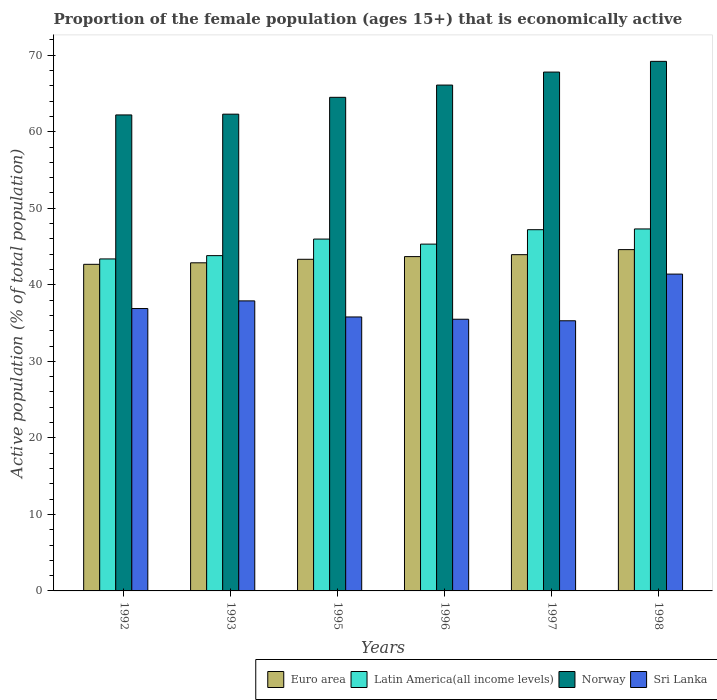How many groups of bars are there?
Offer a very short reply. 6. Are the number of bars per tick equal to the number of legend labels?
Ensure brevity in your answer.  Yes. Are the number of bars on each tick of the X-axis equal?
Provide a short and direct response. Yes. How many bars are there on the 2nd tick from the left?
Make the answer very short. 4. How many bars are there on the 6th tick from the right?
Provide a short and direct response. 4. What is the label of the 6th group of bars from the left?
Keep it short and to the point. 1998. What is the proportion of the female population that is economically active in Euro area in 1996?
Give a very brief answer. 43.69. Across all years, what is the maximum proportion of the female population that is economically active in Euro area?
Make the answer very short. 44.6. Across all years, what is the minimum proportion of the female population that is economically active in Norway?
Keep it short and to the point. 62.2. In which year was the proportion of the female population that is economically active in Latin America(all income levels) minimum?
Provide a succinct answer. 1992. What is the total proportion of the female population that is economically active in Norway in the graph?
Your answer should be very brief. 392.1. What is the difference between the proportion of the female population that is economically active in Latin America(all income levels) in 1995 and that in 1997?
Provide a short and direct response. -1.22. What is the difference between the proportion of the female population that is economically active in Sri Lanka in 1997 and the proportion of the female population that is economically active in Norway in 1998?
Keep it short and to the point. -33.9. What is the average proportion of the female population that is economically active in Euro area per year?
Ensure brevity in your answer.  43.52. In the year 1992, what is the difference between the proportion of the female population that is economically active in Latin America(all income levels) and proportion of the female population that is economically active in Norway?
Make the answer very short. -18.82. What is the ratio of the proportion of the female population that is economically active in Sri Lanka in 1993 to that in 1997?
Give a very brief answer. 1.07. Is the proportion of the female population that is economically active in Sri Lanka in 1992 less than that in 1997?
Your response must be concise. No. What is the difference between the highest and the second highest proportion of the female population that is economically active in Euro area?
Ensure brevity in your answer.  0.66. What is the difference between the highest and the lowest proportion of the female population that is economically active in Sri Lanka?
Make the answer very short. 6.1. In how many years, is the proportion of the female population that is economically active in Sri Lanka greater than the average proportion of the female population that is economically active in Sri Lanka taken over all years?
Offer a very short reply. 2. Is the sum of the proportion of the female population that is economically active in Sri Lanka in 1997 and 1998 greater than the maximum proportion of the female population that is economically active in Latin America(all income levels) across all years?
Provide a succinct answer. Yes. Is it the case that in every year, the sum of the proportion of the female population that is economically active in Latin America(all income levels) and proportion of the female population that is economically active in Euro area is greater than the sum of proportion of the female population that is economically active in Sri Lanka and proportion of the female population that is economically active in Norway?
Your answer should be very brief. No. What does the 2nd bar from the left in 1995 represents?
Make the answer very short. Latin America(all income levels). Are all the bars in the graph horizontal?
Offer a very short reply. No. How many years are there in the graph?
Provide a succinct answer. 6. Are the values on the major ticks of Y-axis written in scientific E-notation?
Give a very brief answer. No. Does the graph contain grids?
Give a very brief answer. No. Where does the legend appear in the graph?
Keep it short and to the point. Bottom right. How are the legend labels stacked?
Offer a very short reply. Horizontal. What is the title of the graph?
Offer a very short reply. Proportion of the female population (ages 15+) that is economically active. What is the label or title of the X-axis?
Make the answer very short. Years. What is the label or title of the Y-axis?
Your answer should be compact. Active population (% of total population). What is the Active population (% of total population) in Euro area in 1992?
Your response must be concise. 42.68. What is the Active population (% of total population) of Latin America(all income levels) in 1992?
Give a very brief answer. 43.38. What is the Active population (% of total population) of Norway in 1992?
Your answer should be very brief. 62.2. What is the Active population (% of total population) of Sri Lanka in 1992?
Keep it short and to the point. 36.9. What is the Active population (% of total population) of Euro area in 1993?
Ensure brevity in your answer.  42.88. What is the Active population (% of total population) of Latin America(all income levels) in 1993?
Ensure brevity in your answer.  43.81. What is the Active population (% of total population) of Norway in 1993?
Offer a very short reply. 62.3. What is the Active population (% of total population) of Sri Lanka in 1993?
Offer a very short reply. 37.9. What is the Active population (% of total population) in Euro area in 1995?
Offer a very short reply. 43.33. What is the Active population (% of total population) of Latin America(all income levels) in 1995?
Provide a succinct answer. 45.98. What is the Active population (% of total population) in Norway in 1995?
Keep it short and to the point. 64.5. What is the Active population (% of total population) in Sri Lanka in 1995?
Make the answer very short. 35.8. What is the Active population (% of total population) of Euro area in 1996?
Offer a terse response. 43.69. What is the Active population (% of total population) of Latin America(all income levels) in 1996?
Make the answer very short. 45.32. What is the Active population (% of total population) in Norway in 1996?
Provide a succinct answer. 66.1. What is the Active population (% of total population) of Sri Lanka in 1996?
Make the answer very short. 35.5. What is the Active population (% of total population) of Euro area in 1997?
Provide a succinct answer. 43.94. What is the Active population (% of total population) in Latin America(all income levels) in 1997?
Provide a short and direct response. 47.2. What is the Active population (% of total population) in Norway in 1997?
Offer a terse response. 67.8. What is the Active population (% of total population) in Sri Lanka in 1997?
Your response must be concise. 35.3. What is the Active population (% of total population) of Euro area in 1998?
Your answer should be very brief. 44.6. What is the Active population (% of total population) of Latin America(all income levels) in 1998?
Give a very brief answer. 47.3. What is the Active population (% of total population) in Norway in 1998?
Offer a terse response. 69.2. What is the Active population (% of total population) in Sri Lanka in 1998?
Your answer should be very brief. 41.4. Across all years, what is the maximum Active population (% of total population) of Euro area?
Your response must be concise. 44.6. Across all years, what is the maximum Active population (% of total population) of Latin America(all income levels)?
Give a very brief answer. 47.3. Across all years, what is the maximum Active population (% of total population) in Norway?
Provide a short and direct response. 69.2. Across all years, what is the maximum Active population (% of total population) in Sri Lanka?
Give a very brief answer. 41.4. Across all years, what is the minimum Active population (% of total population) in Euro area?
Ensure brevity in your answer.  42.68. Across all years, what is the minimum Active population (% of total population) of Latin America(all income levels)?
Offer a very short reply. 43.38. Across all years, what is the minimum Active population (% of total population) in Norway?
Keep it short and to the point. 62.2. Across all years, what is the minimum Active population (% of total population) in Sri Lanka?
Your response must be concise. 35.3. What is the total Active population (% of total population) of Euro area in the graph?
Offer a terse response. 261.11. What is the total Active population (% of total population) of Latin America(all income levels) in the graph?
Provide a short and direct response. 272.99. What is the total Active population (% of total population) of Norway in the graph?
Provide a short and direct response. 392.1. What is the total Active population (% of total population) in Sri Lanka in the graph?
Provide a short and direct response. 222.8. What is the difference between the Active population (% of total population) of Euro area in 1992 and that in 1993?
Offer a terse response. -0.2. What is the difference between the Active population (% of total population) of Latin America(all income levels) in 1992 and that in 1993?
Your answer should be very brief. -0.43. What is the difference between the Active population (% of total population) in Norway in 1992 and that in 1993?
Give a very brief answer. -0.1. What is the difference between the Active population (% of total population) of Euro area in 1992 and that in 1995?
Your answer should be compact. -0.66. What is the difference between the Active population (% of total population) of Latin America(all income levels) in 1992 and that in 1995?
Offer a terse response. -2.6. What is the difference between the Active population (% of total population) of Norway in 1992 and that in 1995?
Your answer should be very brief. -2.3. What is the difference between the Active population (% of total population) in Sri Lanka in 1992 and that in 1995?
Your answer should be compact. 1.1. What is the difference between the Active population (% of total population) of Euro area in 1992 and that in 1996?
Your response must be concise. -1.01. What is the difference between the Active population (% of total population) of Latin America(all income levels) in 1992 and that in 1996?
Ensure brevity in your answer.  -1.94. What is the difference between the Active population (% of total population) of Sri Lanka in 1992 and that in 1996?
Keep it short and to the point. 1.4. What is the difference between the Active population (% of total population) in Euro area in 1992 and that in 1997?
Make the answer very short. -1.26. What is the difference between the Active population (% of total population) of Latin America(all income levels) in 1992 and that in 1997?
Keep it short and to the point. -3.82. What is the difference between the Active population (% of total population) in Sri Lanka in 1992 and that in 1997?
Make the answer very short. 1.6. What is the difference between the Active population (% of total population) of Euro area in 1992 and that in 1998?
Provide a succinct answer. -1.92. What is the difference between the Active population (% of total population) of Latin America(all income levels) in 1992 and that in 1998?
Keep it short and to the point. -3.92. What is the difference between the Active population (% of total population) in Norway in 1992 and that in 1998?
Ensure brevity in your answer.  -7. What is the difference between the Active population (% of total population) in Euro area in 1993 and that in 1995?
Give a very brief answer. -0.46. What is the difference between the Active population (% of total population) of Latin America(all income levels) in 1993 and that in 1995?
Offer a terse response. -2.16. What is the difference between the Active population (% of total population) in Euro area in 1993 and that in 1996?
Make the answer very short. -0.81. What is the difference between the Active population (% of total population) of Latin America(all income levels) in 1993 and that in 1996?
Provide a short and direct response. -1.51. What is the difference between the Active population (% of total population) in Euro area in 1993 and that in 1997?
Your answer should be compact. -1.06. What is the difference between the Active population (% of total population) in Latin America(all income levels) in 1993 and that in 1997?
Your answer should be compact. -3.39. What is the difference between the Active population (% of total population) in Euro area in 1993 and that in 1998?
Make the answer very short. -1.72. What is the difference between the Active population (% of total population) in Latin America(all income levels) in 1993 and that in 1998?
Provide a short and direct response. -3.49. What is the difference between the Active population (% of total population) in Norway in 1993 and that in 1998?
Make the answer very short. -6.9. What is the difference between the Active population (% of total population) of Sri Lanka in 1993 and that in 1998?
Ensure brevity in your answer.  -3.5. What is the difference between the Active population (% of total population) of Euro area in 1995 and that in 1996?
Offer a very short reply. -0.35. What is the difference between the Active population (% of total population) of Latin America(all income levels) in 1995 and that in 1996?
Keep it short and to the point. 0.66. What is the difference between the Active population (% of total population) in Norway in 1995 and that in 1996?
Your answer should be very brief. -1.6. What is the difference between the Active population (% of total population) in Euro area in 1995 and that in 1997?
Your response must be concise. -0.6. What is the difference between the Active population (% of total population) in Latin America(all income levels) in 1995 and that in 1997?
Keep it short and to the point. -1.22. What is the difference between the Active population (% of total population) in Euro area in 1995 and that in 1998?
Keep it short and to the point. -1.26. What is the difference between the Active population (% of total population) in Latin America(all income levels) in 1995 and that in 1998?
Your response must be concise. -1.32. What is the difference between the Active population (% of total population) in Norway in 1995 and that in 1998?
Your answer should be compact. -4.7. What is the difference between the Active population (% of total population) in Euro area in 1996 and that in 1997?
Give a very brief answer. -0.25. What is the difference between the Active population (% of total population) of Latin America(all income levels) in 1996 and that in 1997?
Offer a very short reply. -1.88. What is the difference between the Active population (% of total population) of Sri Lanka in 1996 and that in 1997?
Provide a succinct answer. 0.2. What is the difference between the Active population (% of total population) in Euro area in 1996 and that in 1998?
Provide a short and direct response. -0.91. What is the difference between the Active population (% of total population) in Latin America(all income levels) in 1996 and that in 1998?
Provide a succinct answer. -1.98. What is the difference between the Active population (% of total population) in Norway in 1996 and that in 1998?
Your answer should be compact. -3.1. What is the difference between the Active population (% of total population) of Euro area in 1997 and that in 1998?
Ensure brevity in your answer.  -0.66. What is the difference between the Active population (% of total population) of Latin America(all income levels) in 1997 and that in 1998?
Your answer should be very brief. -0.1. What is the difference between the Active population (% of total population) in Euro area in 1992 and the Active population (% of total population) in Latin America(all income levels) in 1993?
Ensure brevity in your answer.  -1.14. What is the difference between the Active population (% of total population) in Euro area in 1992 and the Active population (% of total population) in Norway in 1993?
Offer a terse response. -19.62. What is the difference between the Active population (% of total population) of Euro area in 1992 and the Active population (% of total population) of Sri Lanka in 1993?
Offer a very short reply. 4.78. What is the difference between the Active population (% of total population) in Latin America(all income levels) in 1992 and the Active population (% of total population) in Norway in 1993?
Keep it short and to the point. -18.92. What is the difference between the Active population (% of total population) in Latin America(all income levels) in 1992 and the Active population (% of total population) in Sri Lanka in 1993?
Offer a very short reply. 5.48. What is the difference between the Active population (% of total population) of Norway in 1992 and the Active population (% of total population) of Sri Lanka in 1993?
Your answer should be compact. 24.3. What is the difference between the Active population (% of total population) of Euro area in 1992 and the Active population (% of total population) of Latin America(all income levels) in 1995?
Provide a short and direct response. -3.3. What is the difference between the Active population (% of total population) in Euro area in 1992 and the Active population (% of total population) in Norway in 1995?
Ensure brevity in your answer.  -21.82. What is the difference between the Active population (% of total population) of Euro area in 1992 and the Active population (% of total population) of Sri Lanka in 1995?
Provide a short and direct response. 6.88. What is the difference between the Active population (% of total population) in Latin America(all income levels) in 1992 and the Active population (% of total population) in Norway in 1995?
Your response must be concise. -21.12. What is the difference between the Active population (% of total population) in Latin America(all income levels) in 1992 and the Active population (% of total population) in Sri Lanka in 1995?
Keep it short and to the point. 7.58. What is the difference between the Active population (% of total population) in Norway in 1992 and the Active population (% of total population) in Sri Lanka in 1995?
Your answer should be very brief. 26.4. What is the difference between the Active population (% of total population) in Euro area in 1992 and the Active population (% of total population) in Latin America(all income levels) in 1996?
Provide a short and direct response. -2.64. What is the difference between the Active population (% of total population) of Euro area in 1992 and the Active population (% of total population) of Norway in 1996?
Provide a succinct answer. -23.42. What is the difference between the Active population (% of total population) in Euro area in 1992 and the Active population (% of total population) in Sri Lanka in 1996?
Provide a short and direct response. 7.18. What is the difference between the Active population (% of total population) in Latin America(all income levels) in 1992 and the Active population (% of total population) in Norway in 1996?
Give a very brief answer. -22.72. What is the difference between the Active population (% of total population) of Latin America(all income levels) in 1992 and the Active population (% of total population) of Sri Lanka in 1996?
Provide a short and direct response. 7.88. What is the difference between the Active population (% of total population) of Norway in 1992 and the Active population (% of total population) of Sri Lanka in 1996?
Make the answer very short. 26.7. What is the difference between the Active population (% of total population) in Euro area in 1992 and the Active population (% of total population) in Latin America(all income levels) in 1997?
Offer a very short reply. -4.52. What is the difference between the Active population (% of total population) in Euro area in 1992 and the Active population (% of total population) in Norway in 1997?
Give a very brief answer. -25.12. What is the difference between the Active population (% of total population) of Euro area in 1992 and the Active population (% of total population) of Sri Lanka in 1997?
Provide a succinct answer. 7.38. What is the difference between the Active population (% of total population) of Latin America(all income levels) in 1992 and the Active population (% of total population) of Norway in 1997?
Keep it short and to the point. -24.42. What is the difference between the Active population (% of total population) of Latin America(all income levels) in 1992 and the Active population (% of total population) of Sri Lanka in 1997?
Your response must be concise. 8.08. What is the difference between the Active population (% of total population) of Norway in 1992 and the Active population (% of total population) of Sri Lanka in 1997?
Give a very brief answer. 26.9. What is the difference between the Active population (% of total population) of Euro area in 1992 and the Active population (% of total population) of Latin America(all income levels) in 1998?
Provide a succinct answer. -4.62. What is the difference between the Active population (% of total population) in Euro area in 1992 and the Active population (% of total population) in Norway in 1998?
Provide a short and direct response. -26.52. What is the difference between the Active population (% of total population) in Euro area in 1992 and the Active population (% of total population) in Sri Lanka in 1998?
Provide a short and direct response. 1.28. What is the difference between the Active population (% of total population) in Latin America(all income levels) in 1992 and the Active population (% of total population) in Norway in 1998?
Keep it short and to the point. -25.82. What is the difference between the Active population (% of total population) in Latin America(all income levels) in 1992 and the Active population (% of total population) in Sri Lanka in 1998?
Keep it short and to the point. 1.98. What is the difference between the Active population (% of total population) in Norway in 1992 and the Active population (% of total population) in Sri Lanka in 1998?
Provide a succinct answer. 20.8. What is the difference between the Active population (% of total population) of Euro area in 1993 and the Active population (% of total population) of Latin America(all income levels) in 1995?
Offer a terse response. -3.1. What is the difference between the Active population (% of total population) in Euro area in 1993 and the Active population (% of total population) in Norway in 1995?
Offer a very short reply. -21.62. What is the difference between the Active population (% of total population) in Euro area in 1993 and the Active population (% of total population) in Sri Lanka in 1995?
Your response must be concise. 7.08. What is the difference between the Active population (% of total population) of Latin America(all income levels) in 1993 and the Active population (% of total population) of Norway in 1995?
Make the answer very short. -20.69. What is the difference between the Active population (% of total population) in Latin America(all income levels) in 1993 and the Active population (% of total population) in Sri Lanka in 1995?
Offer a terse response. 8.01. What is the difference between the Active population (% of total population) in Euro area in 1993 and the Active population (% of total population) in Latin America(all income levels) in 1996?
Your answer should be compact. -2.44. What is the difference between the Active population (% of total population) in Euro area in 1993 and the Active population (% of total population) in Norway in 1996?
Offer a very short reply. -23.22. What is the difference between the Active population (% of total population) of Euro area in 1993 and the Active population (% of total population) of Sri Lanka in 1996?
Offer a terse response. 7.38. What is the difference between the Active population (% of total population) in Latin America(all income levels) in 1993 and the Active population (% of total population) in Norway in 1996?
Your answer should be very brief. -22.29. What is the difference between the Active population (% of total population) in Latin America(all income levels) in 1993 and the Active population (% of total population) in Sri Lanka in 1996?
Your answer should be very brief. 8.31. What is the difference between the Active population (% of total population) in Norway in 1993 and the Active population (% of total population) in Sri Lanka in 1996?
Make the answer very short. 26.8. What is the difference between the Active population (% of total population) in Euro area in 1993 and the Active population (% of total population) in Latin America(all income levels) in 1997?
Offer a terse response. -4.33. What is the difference between the Active population (% of total population) in Euro area in 1993 and the Active population (% of total population) in Norway in 1997?
Make the answer very short. -24.92. What is the difference between the Active population (% of total population) in Euro area in 1993 and the Active population (% of total population) in Sri Lanka in 1997?
Provide a succinct answer. 7.58. What is the difference between the Active population (% of total population) in Latin America(all income levels) in 1993 and the Active population (% of total population) in Norway in 1997?
Give a very brief answer. -23.99. What is the difference between the Active population (% of total population) in Latin America(all income levels) in 1993 and the Active population (% of total population) in Sri Lanka in 1997?
Your answer should be very brief. 8.51. What is the difference between the Active population (% of total population) in Euro area in 1993 and the Active population (% of total population) in Latin America(all income levels) in 1998?
Offer a terse response. -4.43. What is the difference between the Active population (% of total population) of Euro area in 1993 and the Active population (% of total population) of Norway in 1998?
Give a very brief answer. -26.32. What is the difference between the Active population (% of total population) in Euro area in 1993 and the Active population (% of total population) in Sri Lanka in 1998?
Your answer should be compact. 1.48. What is the difference between the Active population (% of total population) in Latin America(all income levels) in 1993 and the Active population (% of total population) in Norway in 1998?
Make the answer very short. -25.39. What is the difference between the Active population (% of total population) of Latin America(all income levels) in 1993 and the Active population (% of total population) of Sri Lanka in 1998?
Keep it short and to the point. 2.41. What is the difference between the Active population (% of total population) in Norway in 1993 and the Active population (% of total population) in Sri Lanka in 1998?
Keep it short and to the point. 20.9. What is the difference between the Active population (% of total population) of Euro area in 1995 and the Active population (% of total population) of Latin America(all income levels) in 1996?
Make the answer very short. -1.98. What is the difference between the Active population (% of total population) in Euro area in 1995 and the Active population (% of total population) in Norway in 1996?
Ensure brevity in your answer.  -22.77. What is the difference between the Active population (% of total population) in Euro area in 1995 and the Active population (% of total population) in Sri Lanka in 1996?
Provide a succinct answer. 7.83. What is the difference between the Active population (% of total population) in Latin America(all income levels) in 1995 and the Active population (% of total population) in Norway in 1996?
Provide a succinct answer. -20.12. What is the difference between the Active population (% of total population) of Latin America(all income levels) in 1995 and the Active population (% of total population) of Sri Lanka in 1996?
Your answer should be very brief. 10.48. What is the difference between the Active population (% of total population) in Norway in 1995 and the Active population (% of total population) in Sri Lanka in 1996?
Your response must be concise. 29. What is the difference between the Active population (% of total population) of Euro area in 1995 and the Active population (% of total population) of Latin America(all income levels) in 1997?
Offer a terse response. -3.87. What is the difference between the Active population (% of total population) of Euro area in 1995 and the Active population (% of total population) of Norway in 1997?
Your answer should be compact. -24.47. What is the difference between the Active population (% of total population) of Euro area in 1995 and the Active population (% of total population) of Sri Lanka in 1997?
Ensure brevity in your answer.  8.03. What is the difference between the Active population (% of total population) in Latin America(all income levels) in 1995 and the Active population (% of total population) in Norway in 1997?
Offer a very short reply. -21.82. What is the difference between the Active population (% of total population) in Latin America(all income levels) in 1995 and the Active population (% of total population) in Sri Lanka in 1997?
Offer a very short reply. 10.68. What is the difference between the Active population (% of total population) of Norway in 1995 and the Active population (% of total population) of Sri Lanka in 1997?
Your response must be concise. 29.2. What is the difference between the Active population (% of total population) of Euro area in 1995 and the Active population (% of total population) of Latin America(all income levels) in 1998?
Ensure brevity in your answer.  -3.97. What is the difference between the Active population (% of total population) of Euro area in 1995 and the Active population (% of total population) of Norway in 1998?
Offer a terse response. -25.87. What is the difference between the Active population (% of total population) of Euro area in 1995 and the Active population (% of total population) of Sri Lanka in 1998?
Give a very brief answer. 1.93. What is the difference between the Active population (% of total population) in Latin America(all income levels) in 1995 and the Active population (% of total population) in Norway in 1998?
Make the answer very short. -23.22. What is the difference between the Active population (% of total population) of Latin America(all income levels) in 1995 and the Active population (% of total population) of Sri Lanka in 1998?
Keep it short and to the point. 4.58. What is the difference between the Active population (% of total population) in Norway in 1995 and the Active population (% of total population) in Sri Lanka in 1998?
Offer a terse response. 23.1. What is the difference between the Active population (% of total population) in Euro area in 1996 and the Active population (% of total population) in Latin America(all income levels) in 1997?
Provide a succinct answer. -3.52. What is the difference between the Active population (% of total population) in Euro area in 1996 and the Active population (% of total population) in Norway in 1997?
Your response must be concise. -24.11. What is the difference between the Active population (% of total population) of Euro area in 1996 and the Active population (% of total population) of Sri Lanka in 1997?
Your response must be concise. 8.39. What is the difference between the Active population (% of total population) of Latin America(all income levels) in 1996 and the Active population (% of total population) of Norway in 1997?
Your answer should be very brief. -22.48. What is the difference between the Active population (% of total population) in Latin America(all income levels) in 1996 and the Active population (% of total population) in Sri Lanka in 1997?
Keep it short and to the point. 10.02. What is the difference between the Active population (% of total population) of Norway in 1996 and the Active population (% of total population) of Sri Lanka in 1997?
Offer a very short reply. 30.8. What is the difference between the Active population (% of total population) in Euro area in 1996 and the Active population (% of total population) in Latin America(all income levels) in 1998?
Make the answer very short. -3.62. What is the difference between the Active population (% of total population) of Euro area in 1996 and the Active population (% of total population) of Norway in 1998?
Your answer should be compact. -25.51. What is the difference between the Active population (% of total population) of Euro area in 1996 and the Active population (% of total population) of Sri Lanka in 1998?
Offer a very short reply. 2.29. What is the difference between the Active population (% of total population) in Latin America(all income levels) in 1996 and the Active population (% of total population) in Norway in 1998?
Make the answer very short. -23.88. What is the difference between the Active population (% of total population) in Latin America(all income levels) in 1996 and the Active population (% of total population) in Sri Lanka in 1998?
Your answer should be compact. 3.92. What is the difference between the Active population (% of total population) of Norway in 1996 and the Active population (% of total population) of Sri Lanka in 1998?
Offer a terse response. 24.7. What is the difference between the Active population (% of total population) of Euro area in 1997 and the Active population (% of total population) of Latin America(all income levels) in 1998?
Ensure brevity in your answer.  -3.36. What is the difference between the Active population (% of total population) in Euro area in 1997 and the Active population (% of total population) in Norway in 1998?
Provide a short and direct response. -25.26. What is the difference between the Active population (% of total population) in Euro area in 1997 and the Active population (% of total population) in Sri Lanka in 1998?
Keep it short and to the point. 2.54. What is the difference between the Active population (% of total population) in Latin America(all income levels) in 1997 and the Active population (% of total population) in Norway in 1998?
Ensure brevity in your answer.  -22. What is the difference between the Active population (% of total population) in Latin America(all income levels) in 1997 and the Active population (% of total population) in Sri Lanka in 1998?
Make the answer very short. 5.8. What is the difference between the Active population (% of total population) in Norway in 1997 and the Active population (% of total population) in Sri Lanka in 1998?
Provide a short and direct response. 26.4. What is the average Active population (% of total population) in Euro area per year?
Provide a succinct answer. 43.52. What is the average Active population (% of total population) in Latin America(all income levels) per year?
Keep it short and to the point. 45.5. What is the average Active population (% of total population) of Norway per year?
Keep it short and to the point. 65.35. What is the average Active population (% of total population) of Sri Lanka per year?
Offer a terse response. 37.13. In the year 1992, what is the difference between the Active population (% of total population) of Euro area and Active population (% of total population) of Latin America(all income levels)?
Your response must be concise. -0.71. In the year 1992, what is the difference between the Active population (% of total population) in Euro area and Active population (% of total population) in Norway?
Offer a very short reply. -19.52. In the year 1992, what is the difference between the Active population (% of total population) of Euro area and Active population (% of total population) of Sri Lanka?
Your answer should be compact. 5.78. In the year 1992, what is the difference between the Active population (% of total population) of Latin America(all income levels) and Active population (% of total population) of Norway?
Keep it short and to the point. -18.82. In the year 1992, what is the difference between the Active population (% of total population) in Latin America(all income levels) and Active population (% of total population) in Sri Lanka?
Offer a terse response. 6.48. In the year 1992, what is the difference between the Active population (% of total population) in Norway and Active population (% of total population) in Sri Lanka?
Provide a succinct answer. 25.3. In the year 1993, what is the difference between the Active population (% of total population) of Euro area and Active population (% of total population) of Latin America(all income levels)?
Make the answer very short. -0.94. In the year 1993, what is the difference between the Active population (% of total population) of Euro area and Active population (% of total population) of Norway?
Your answer should be very brief. -19.42. In the year 1993, what is the difference between the Active population (% of total population) in Euro area and Active population (% of total population) in Sri Lanka?
Offer a terse response. 4.98. In the year 1993, what is the difference between the Active population (% of total population) in Latin America(all income levels) and Active population (% of total population) in Norway?
Offer a terse response. -18.49. In the year 1993, what is the difference between the Active population (% of total population) in Latin America(all income levels) and Active population (% of total population) in Sri Lanka?
Offer a very short reply. 5.91. In the year 1993, what is the difference between the Active population (% of total population) of Norway and Active population (% of total population) of Sri Lanka?
Your response must be concise. 24.4. In the year 1995, what is the difference between the Active population (% of total population) in Euro area and Active population (% of total population) in Latin America(all income levels)?
Offer a terse response. -2.64. In the year 1995, what is the difference between the Active population (% of total population) of Euro area and Active population (% of total population) of Norway?
Keep it short and to the point. -21.17. In the year 1995, what is the difference between the Active population (% of total population) in Euro area and Active population (% of total population) in Sri Lanka?
Your answer should be compact. 7.53. In the year 1995, what is the difference between the Active population (% of total population) of Latin America(all income levels) and Active population (% of total population) of Norway?
Your answer should be very brief. -18.52. In the year 1995, what is the difference between the Active population (% of total population) in Latin America(all income levels) and Active population (% of total population) in Sri Lanka?
Keep it short and to the point. 10.18. In the year 1995, what is the difference between the Active population (% of total population) of Norway and Active population (% of total population) of Sri Lanka?
Your answer should be very brief. 28.7. In the year 1996, what is the difference between the Active population (% of total population) of Euro area and Active population (% of total population) of Latin America(all income levels)?
Ensure brevity in your answer.  -1.63. In the year 1996, what is the difference between the Active population (% of total population) in Euro area and Active population (% of total population) in Norway?
Keep it short and to the point. -22.41. In the year 1996, what is the difference between the Active population (% of total population) of Euro area and Active population (% of total population) of Sri Lanka?
Offer a very short reply. 8.19. In the year 1996, what is the difference between the Active population (% of total population) in Latin America(all income levels) and Active population (% of total population) in Norway?
Provide a succinct answer. -20.78. In the year 1996, what is the difference between the Active population (% of total population) of Latin America(all income levels) and Active population (% of total population) of Sri Lanka?
Keep it short and to the point. 9.82. In the year 1996, what is the difference between the Active population (% of total population) in Norway and Active population (% of total population) in Sri Lanka?
Give a very brief answer. 30.6. In the year 1997, what is the difference between the Active population (% of total population) of Euro area and Active population (% of total population) of Latin America(all income levels)?
Your answer should be compact. -3.26. In the year 1997, what is the difference between the Active population (% of total population) of Euro area and Active population (% of total population) of Norway?
Offer a very short reply. -23.86. In the year 1997, what is the difference between the Active population (% of total population) of Euro area and Active population (% of total population) of Sri Lanka?
Your answer should be very brief. 8.64. In the year 1997, what is the difference between the Active population (% of total population) in Latin America(all income levels) and Active population (% of total population) in Norway?
Give a very brief answer. -20.6. In the year 1997, what is the difference between the Active population (% of total population) of Latin America(all income levels) and Active population (% of total population) of Sri Lanka?
Provide a short and direct response. 11.9. In the year 1997, what is the difference between the Active population (% of total population) in Norway and Active population (% of total population) in Sri Lanka?
Make the answer very short. 32.5. In the year 1998, what is the difference between the Active population (% of total population) in Euro area and Active population (% of total population) in Latin America(all income levels)?
Keep it short and to the point. -2.7. In the year 1998, what is the difference between the Active population (% of total population) of Euro area and Active population (% of total population) of Norway?
Offer a very short reply. -24.6. In the year 1998, what is the difference between the Active population (% of total population) in Euro area and Active population (% of total population) in Sri Lanka?
Your response must be concise. 3.2. In the year 1998, what is the difference between the Active population (% of total population) in Latin America(all income levels) and Active population (% of total population) in Norway?
Keep it short and to the point. -21.9. In the year 1998, what is the difference between the Active population (% of total population) in Latin America(all income levels) and Active population (% of total population) in Sri Lanka?
Keep it short and to the point. 5.9. In the year 1998, what is the difference between the Active population (% of total population) in Norway and Active population (% of total population) in Sri Lanka?
Offer a very short reply. 27.8. What is the ratio of the Active population (% of total population) in Latin America(all income levels) in 1992 to that in 1993?
Ensure brevity in your answer.  0.99. What is the ratio of the Active population (% of total population) in Norway in 1992 to that in 1993?
Give a very brief answer. 1. What is the ratio of the Active population (% of total population) in Sri Lanka in 1992 to that in 1993?
Ensure brevity in your answer.  0.97. What is the ratio of the Active population (% of total population) in Euro area in 1992 to that in 1995?
Provide a short and direct response. 0.98. What is the ratio of the Active population (% of total population) of Latin America(all income levels) in 1992 to that in 1995?
Offer a terse response. 0.94. What is the ratio of the Active population (% of total population) in Norway in 1992 to that in 1995?
Keep it short and to the point. 0.96. What is the ratio of the Active population (% of total population) of Sri Lanka in 1992 to that in 1995?
Keep it short and to the point. 1.03. What is the ratio of the Active population (% of total population) in Euro area in 1992 to that in 1996?
Your answer should be compact. 0.98. What is the ratio of the Active population (% of total population) in Latin America(all income levels) in 1992 to that in 1996?
Offer a very short reply. 0.96. What is the ratio of the Active population (% of total population) in Norway in 1992 to that in 1996?
Your response must be concise. 0.94. What is the ratio of the Active population (% of total population) of Sri Lanka in 1992 to that in 1996?
Make the answer very short. 1.04. What is the ratio of the Active population (% of total population) of Euro area in 1992 to that in 1997?
Offer a terse response. 0.97. What is the ratio of the Active population (% of total population) in Latin America(all income levels) in 1992 to that in 1997?
Your response must be concise. 0.92. What is the ratio of the Active population (% of total population) in Norway in 1992 to that in 1997?
Give a very brief answer. 0.92. What is the ratio of the Active population (% of total population) of Sri Lanka in 1992 to that in 1997?
Provide a short and direct response. 1.05. What is the ratio of the Active population (% of total population) of Euro area in 1992 to that in 1998?
Provide a succinct answer. 0.96. What is the ratio of the Active population (% of total population) of Latin America(all income levels) in 1992 to that in 1998?
Offer a very short reply. 0.92. What is the ratio of the Active population (% of total population) of Norway in 1992 to that in 1998?
Provide a succinct answer. 0.9. What is the ratio of the Active population (% of total population) in Sri Lanka in 1992 to that in 1998?
Provide a short and direct response. 0.89. What is the ratio of the Active population (% of total population) in Euro area in 1993 to that in 1995?
Provide a short and direct response. 0.99. What is the ratio of the Active population (% of total population) of Latin America(all income levels) in 1993 to that in 1995?
Offer a very short reply. 0.95. What is the ratio of the Active population (% of total population) in Norway in 1993 to that in 1995?
Your response must be concise. 0.97. What is the ratio of the Active population (% of total population) of Sri Lanka in 1993 to that in 1995?
Make the answer very short. 1.06. What is the ratio of the Active population (% of total population) in Euro area in 1993 to that in 1996?
Keep it short and to the point. 0.98. What is the ratio of the Active population (% of total population) of Latin America(all income levels) in 1993 to that in 1996?
Provide a short and direct response. 0.97. What is the ratio of the Active population (% of total population) in Norway in 1993 to that in 1996?
Give a very brief answer. 0.94. What is the ratio of the Active population (% of total population) of Sri Lanka in 1993 to that in 1996?
Your answer should be very brief. 1.07. What is the ratio of the Active population (% of total population) in Euro area in 1993 to that in 1997?
Ensure brevity in your answer.  0.98. What is the ratio of the Active population (% of total population) in Latin America(all income levels) in 1993 to that in 1997?
Offer a very short reply. 0.93. What is the ratio of the Active population (% of total population) in Norway in 1993 to that in 1997?
Provide a succinct answer. 0.92. What is the ratio of the Active population (% of total population) of Sri Lanka in 1993 to that in 1997?
Make the answer very short. 1.07. What is the ratio of the Active population (% of total population) of Euro area in 1993 to that in 1998?
Ensure brevity in your answer.  0.96. What is the ratio of the Active population (% of total population) of Latin America(all income levels) in 1993 to that in 1998?
Provide a succinct answer. 0.93. What is the ratio of the Active population (% of total population) of Norway in 1993 to that in 1998?
Your response must be concise. 0.9. What is the ratio of the Active population (% of total population) in Sri Lanka in 1993 to that in 1998?
Make the answer very short. 0.92. What is the ratio of the Active population (% of total population) of Latin America(all income levels) in 1995 to that in 1996?
Keep it short and to the point. 1.01. What is the ratio of the Active population (% of total population) of Norway in 1995 to that in 1996?
Give a very brief answer. 0.98. What is the ratio of the Active population (% of total population) of Sri Lanka in 1995 to that in 1996?
Give a very brief answer. 1.01. What is the ratio of the Active population (% of total population) of Euro area in 1995 to that in 1997?
Provide a short and direct response. 0.99. What is the ratio of the Active population (% of total population) in Latin America(all income levels) in 1995 to that in 1997?
Keep it short and to the point. 0.97. What is the ratio of the Active population (% of total population) of Norway in 1995 to that in 1997?
Offer a terse response. 0.95. What is the ratio of the Active population (% of total population) of Sri Lanka in 1995 to that in 1997?
Offer a terse response. 1.01. What is the ratio of the Active population (% of total population) of Euro area in 1995 to that in 1998?
Give a very brief answer. 0.97. What is the ratio of the Active population (% of total population) of Norway in 1995 to that in 1998?
Keep it short and to the point. 0.93. What is the ratio of the Active population (% of total population) of Sri Lanka in 1995 to that in 1998?
Offer a very short reply. 0.86. What is the ratio of the Active population (% of total population) of Latin America(all income levels) in 1996 to that in 1997?
Your answer should be very brief. 0.96. What is the ratio of the Active population (% of total population) of Norway in 1996 to that in 1997?
Provide a succinct answer. 0.97. What is the ratio of the Active population (% of total population) of Euro area in 1996 to that in 1998?
Offer a terse response. 0.98. What is the ratio of the Active population (% of total population) of Latin America(all income levels) in 1996 to that in 1998?
Offer a terse response. 0.96. What is the ratio of the Active population (% of total population) in Norway in 1996 to that in 1998?
Ensure brevity in your answer.  0.96. What is the ratio of the Active population (% of total population) of Sri Lanka in 1996 to that in 1998?
Make the answer very short. 0.86. What is the ratio of the Active population (% of total population) of Euro area in 1997 to that in 1998?
Offer a very short reply. 0.99. What is the ratio of the Active population (% of total population) of Latin America(all income levels) in 1997 to that in 1998?
Offer a terse response. 1. What is the ratio of the Active population (% of total population) of Norway in 1997 to that in 1998?
Your response must be concise. 0.98. What is the ratio of the Active population (% of total population) in Sri Lanka in 1997 to that in 1998?
Your response must be concise. 0.85. What is the difference between the highest and the second highest Active population (% of total population) in Euro area?
Your answer should be compact. 0.66. What is the difference between the highest and the second highest Active population (% of total population) in Latin America(all income levels)?
Your answer should be very brief. 0.1. What is the difference between the highest and the second highest Active population (% of total population) in Norway?
Provide a short and direct response. 1.4. What is the difference between the highest and the second highest Active population (% of total population) in Sri Lanka?
Your answer should be compact. 3.5. What is the difference between the highest and the lowest Active population (% of total population) in Euro area?
Your answer should be very brief. 1.92. What is the difference between the highest and the lowest Active population (% of total population) in Latin America(all income levels)?
Give a very brief answer. 3.92. 